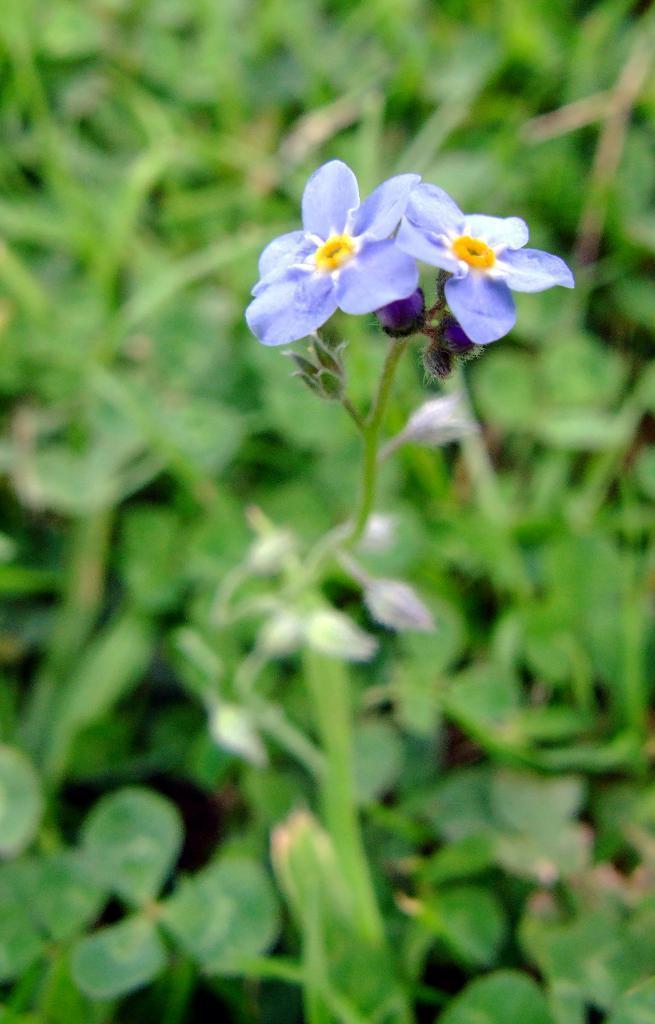Can you describe this image briefly? In the center of the picture there are flowers and a stem. The background is blurred. In the background there is greenery. 